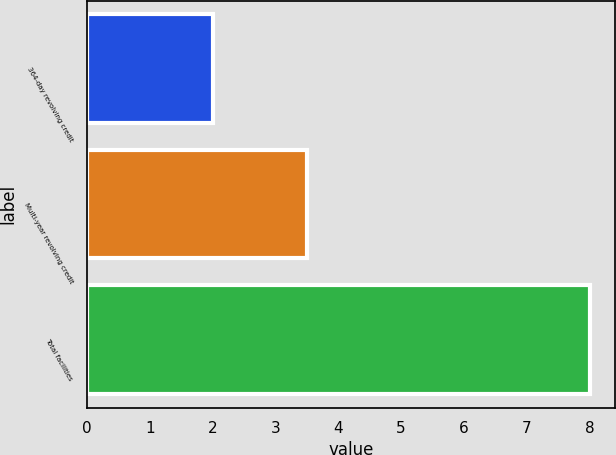Convert chart to OTSL. <chart><loc_0><loc_0><loc_500><loc_500><bar_chart><fcel>364-day revolving credit<fcel>Multi-year revolving credit<fcel>Total facilities<nl><fcel>2<fcel>3.5<fcel>8<nl></chart> 